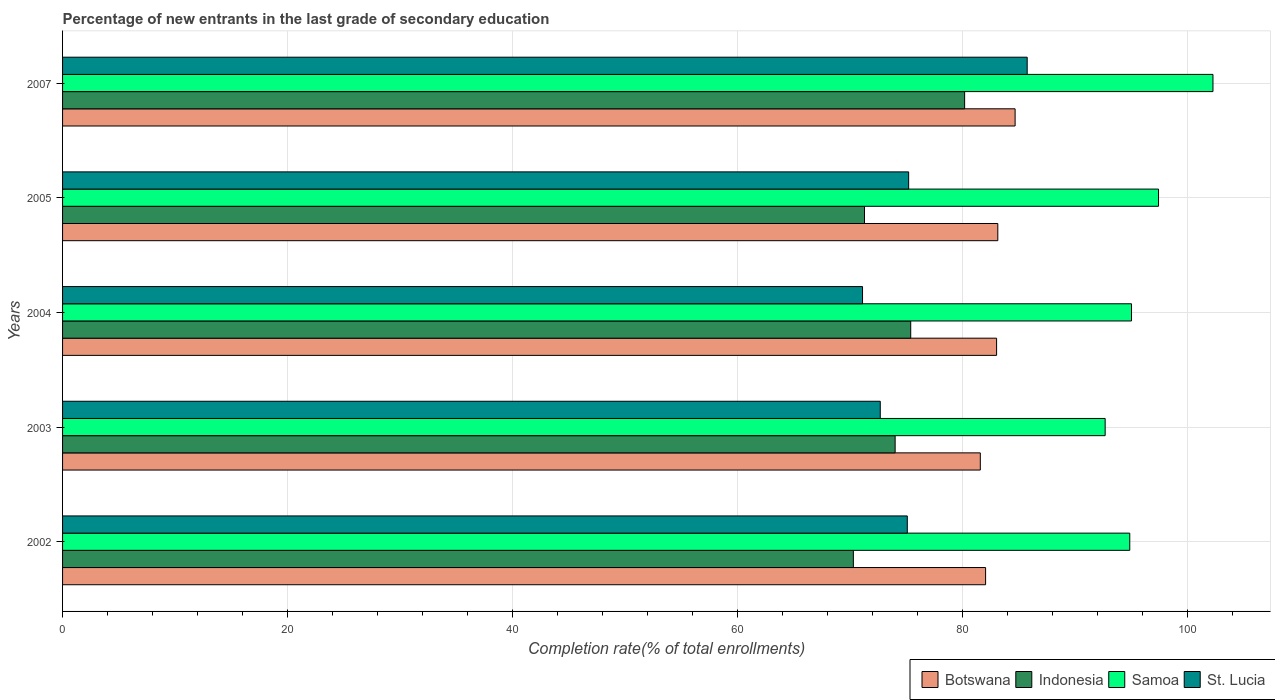How many different coloured bars are there?
Your answer should be compact. 4. Are the number of bars per tick equal to the number of legend labels?
Your answer should be compact. Yes. How many bars are there on the 4th tick from the top?
Ensure brevity in your answer.  4. How many bars are there on the 2nd tick from the bottom?
Your answer should be very brief. 4. In how many cases, is the number of bars for a given year not equal to the number of legend labels?
Provide a short and direct response. 0. What is the percentage of new entrants in Samoa in 2002?
Your answer should be very brief. 94.86. Across all years, what is the maximum percentage of new entrants in St. Lucia?
Make the answer very short. 85.74. Across all years, what is the minimum percentage of new entrants in Indonesia?
Provide a short and direct response. 70.29. In which year was the percentage of new entrants in Samoa maximum?
Offer a very short reply. 2007. In which year was the percentage of new entrants in St. Lucia minimum?
Your answer should be very brief. 2004. What is the total percentage of new entrants in Botswana in the graph?
Offer a very short reply. 414.44. What is the difference between the percentage of new entrants in Indonesia in 2004 and that in 2007?
Your answer should be compact. -4.79. What is the difference between the percentage of new entrants in Samoa in 2005 and the percentage of new entrants in St. Lucia in 2003?
Your answer should be very brief. 24.73. What is the average percentage of new entrants in St. Lucia per year?
Offer a very short reply. 75.97. In the year 2004, what is the difference between the percentage of new entrants in St. Lucia and percentage of new entrants in Indonesia?
Give a very brief answer. -4.28. In how many years, is the percentage of new entrants in St. Lucia greater than 92 %?
Offer a very short reply. 0. What is the ratio of the percentage of new entrants in Botswana in 2003 to that in 2007?
Provide a short and direct response. 0.96. Is the percentage of new entrants in Botswana in 2004 less than that in 2007?
Your response must be concise. Yes. Is the difference between the percentage of new entrants in St. Lucia in 2003 and 2005 greater than the difference between the percentage of new entrants in Indonesia in 2003 and 2005?
Your answer should be very brief. No. What is the difference between the highest and the second highest percentage of new entrants in Samoa?
Your answer should be compact. 4.84. What is the difference between the highest and the lowest percentage of new entrants in Botswana?
Offer a terse response. 3.09. Is the sum of the percentage of new entrants in Samoa in 2002 and 2004 greater than the maximum percentage of new entrants in Botswana across all years?
Ensure brevity in your answer.  Yes. Is it the case that in every year, the sum of the percentage of new entrants in Indonesia and percentage of new entrants in Samoa is greater than the sum of percentage of new entrants in Botswana and percentage of new entrants in St. Lucia?
Keep it short and to the point. Yes. What does the 2nd bar from the top in 2003 represents?
Ensure brevity in your answer.  Samoa. What does the 1st bar from the bottom in 2007 represents?
Ensure brevity in your answer.  Botswana. Is it the case that in every year, the sum of the percentage of new entrants in Botswana and percentage of new entrants in Indonesia is greater than the percentage of new entrants in Samoa?
Make the answer very short. Yes. How many bars are there?
Ensure brevity in your answer.  20. What is the difference between two consecutive major ticks on the X-axis?
Keep it short and to the point. 20. Are the values on the major ticks of X-axis written in scientific E-notation?
Provide a short and direct response. No. How many legend labels are there?
Keep it short and to the point. 4. How are the legend labels stacked?
Your response must be concise. Horizontal. What is the title of the graph?
Offer a very short reply. Percentage of new entrants in the last grade of secondary education. Does "Bahrain" appear as one of the legend labels in the graph?
Provide a succinct answer. No. What is the label or title of the X-axis?
Your answer should be compact. Completion rate(% of total enrollments). What is the Completion rate(% of total enrollments) in Botswana in 2002?
Make the answer very short. 82.05. What is the Completion rate(% of total enrollments) in Indonesia in 2002?
Offer a terse response. 70.29. What is the Completion rate(% of total enrollments) of Samoa in 2002?
Provide a short and direct response. 94.86. What is the Completion rate(% of total enrollments) of St. Lucia in 2002?
Ensure brevity in your answer.  75.09. What is the Completion rate(% of total enrollments) in Botswana in 2003?
Your answer should be very brief. 81.58. What is the Completion rate(% of total enrollments) of Indonesia in 2003?
Make the answer very short. 74.01. What is the Completion rate(% of total enrollments) in Samoa in 2003?
Provide a short and direct response. 92.67. What is the Completion rate(% of total enrollments) in St. Lucia in 2003?
Give a very brief answer. 72.68. What is the Completion rate(% of total enrollments) of Botswana in 2004?
Ensure brevity in your answer.  83.02. What is the Completion rate(% of total enrollments) of Indonesia in 2004?
Your response must be concise. 75.39. What is the Completion rate(% of total enrollments) in Samoa in 2004?
Make the answer very short. 95.01. What is the Completion rate(% of total enrollments) of St. Lucia in 2004?
Offer a very short reply. 71.11. What is the Completion rate(% of total enrollments) of Botswana in 2005?
Provide a short and direct response. 83.13. What is the Completion rate(% of total enrollments) of Indonesia in 2005?
Offer a terse response. 71.28. What is the Completion rate(% of total enrollments) of Samoa in 2005?
Your answer should be very brief. 97.42. What is the Completion rate(% of total enrollments) of St. Lucia in 2005?
Provide a short and direct response. 75.21. What is the Completion rate(% of total enrollments) in Botswana in 2007?
Make the answer very short. 84.67. What is the Completion rate(% of total enrollments) of Indonesia in 2007?
Your answer should be compact. 80.18. What is the Completion rate(% of total enrollments) in Samoa in 2007?
Your answer should be very brief. 102.26. What is the Completion rate(% of total enrollments) in St. Lucia in 2007?
Your answer should be compact. 85.74. Across all years, what is the maximum Completion rate(% of total enrollments) of Botswana?
Give a very brief answer. 84.67. Across all years, what is the maximum Completion rate(% of total enrollments) of Indonesia?
Your answer should be very brief. 80.18. Across all years, what is the maximum Completion rate(% of total enrollments) in Samoa?
Offer a terse response. 102.26. Across all years, what is the maximum Completion rate(% of total enrollments) of St. Lucia?
Offer a very short reply. 85.74. Across all years, what is the minimum Completion rate(% of total enrollments) of Botswana?
Make the answer very short. 81.58. Across all years, what is the minimum Completion rate(% of total enrollments) of Indonesia?
Ensure brevity in your answer.  70.29. Across all years, what is the minimum Completion rate(% of total enrollments) of Samoa?
Make the answer very short. 92.67. Across all years, what is the minimum Completion rate(% of total enrollments) in St. Lucia?
Your response must be concise. 71.11. What is the total Completion rate(% of total enrollments) of Botswana in the graph?
Your response must be concise. 414.44. What is the total Completion rate(% of total enrollments) of Indonesia in the graph?
Provide a short and direct response. 371.15. What is the total Completion rate(% of total enrollments) of Samoa in the graph?
Give a very brief answer. 482.22. What is the total Completion rate(% of total enrollments) of St. Lucia in the graph?
Ensure brevity in your answer.  379.83. What is the difference between the Completion rate(% of total enrollments) in Botswana in 2002 and that in 2003?
Provide a succinct answer. 0.47. What is the difference between the Completion rate(% of total enrollments) of Indonesia in 2002 and that in 2003?
Provide a short and direct response. -3.71. What is the difference between the Completion rate(% of total enrollments) in Samoa in 2002 and that in 2003?
Give a very brief answer. 2.19. What is the difference between the Completion rate(% of total enrollments) of St. Lucia in 2002 and that in 2003?
Offer a very short reply. 2.4. What is the difference between the Completion rate(% of total enrollments) of Botswana in 2002 and that in 2004?
Your answer should be very brief. -0.98. What is the difference between the Completion rate(% of total enrollments) of Indonesia in 2002 and that in 2004?
Your answer should be compact. -5.1. What is the difference between the Completion rate(% of total enrollments) of Samoa in 2002 and that in 2004?
Offer a terse response. -0.15. What is the difference between the Completion rate(% of total enrollments) in St. Lucia in 2002 and that in 2004?
Provide a succinct answer. 3.98. What is the difference between the Completion rate(% of total enrollments) of Botswana in 2002 and that in 2005?
Offer a very short reply. -1.08. What is the difference between the Completion rate(% of total enrollments) of Indonesia in 2002 and that in 2005?
Your response must be concise. -0.99. What is the difference between the Completion rate(% of total enrollments) of Samoa in 2002 and that in 2005?
Your answer should be compact. -2.56. What is the difference between the Completion rate(% of total enrollments) in St. Lucia in 2002 and that in 2005?
Provide a succinct answer. -0.12. What is the difference between the Completion rate(% of total enrollments) in Botswana in 2002 and that in 2007?
Your answer should be compact. -2.62. What is the difference between the Completion rate(% of total enrollments) in Indonesia in 2002 and that in 2007?
Make the answer very short. -9.89. What is the difference between the Completion rate(% of total enrollments) of Samoa in 2002 and that in 2007?
Provide a short and direct response. -7.4. What is the difference between the Completion rate(% of total enrollments) of St. Lucia in 2002 and that in 2007?
Make the answer very short. -10.66. What is the difference between the Completion rate(% of total enrollments) in Botswana in 2003 and that in 2004?
Your answer should be compact. -1.45. What is the difference between the Completion rate(% of total enrollments) of Indonesia in 2003 and that in 2004?
Your answer should be very brief. -1.38. What is the difference between the Completion rate(% of total enrollments) of Samoa in 2003 and that in 2004?
Ensure brevity in your answer.  -2.34. What is the difference between the Completion rate(% of total enrollments) of St. Lucia in 2003 and that in 2004?
Provide a succinct answer. 1.58. What is the difference between the Completion rate(% of total enrollments) in Botswana in 2003 and that in 2005?
Provide a short and direct response. -1.56. What is the difference between the Completion rate(% of total enrollments) of Indonesia in 2003 and that in 2005?
Keep it short and to the point. 2.72. What is the difference between the Completion rate(% of total enrollments) in Samoa in 2003 and that in 2005?
Provide a succinct answer. -4.74. What is the difference between the Completion rate(% of total enrollments) in St. Lucia in 2003 and that in 2005?
Make the answer very short. -2.52. What is the difference between the Completion rate(% of total enrollments) in Botswana in 2003 and that in 2007?
Keep it short and to the point. -3.09. What is the difference between the Completion rate(% of total enrollments) of Indonesia in 2003 and that in 2007?
Your answer should be very brief. -6.18. What is the difference between the Completion rate(% of total enrollments) in Samoa in 2003 and that in 2007?
Your response must be concise. -9.58. What is the difference between the Completion rate(% of total enrollments) of St. Lucia in 2003 and that in 2007?
Ensure brevity in your answer.  -13.06. What is the difference between the Completion rate(% of total enrollments) of Botswana in 2004 and that in 2005?
Ensure brevity in your answer.  -0.11. What is the difference between the Completion rate(% of total enrollments) of Indonesia in 2004 and that in 2005?
Give a very brief answer. 4.11. What is the difference between the Completion rate(% of total enrollments) in Samoa in 2004 and that in 2005?
Ensure brevity in your answer.  -2.4. What is the difference between the Completion rate(% of total enrollments) of St. Lucia in 2004 and that in 2005?
Offer a terse response. -4.1. What is the difference between the Completion rate(% of total enrollments) in Botswana in 2004 and that in 2007?
Provide a short and direct response. -1.65. What is the difference between the Completion rate(% of total enrollments) in Indonesia in 2004 and that in 2007?
Your answer should be compact. -4.79. What is the difference between the Completion rate(% of total enrollments) of Samoa in 2004 and that in 2007?
Keep it short and to the point. -7.24. What is the difference between the Completion rate(% of total enrollments) of St. Lucia in 2004 and that in 2007?
Keep it short and to the point. -14.64. What is the difference between the Completion rate(% of total enrollments) in Botswana in 2005 and that in 2007?
Provide a short and direct response. -1.54. What is the difference between the Completion rate(% of total enrollments) in Indonesia in 2005 and that in 2007?
Keep it short and to the point. -8.9. What is the difference between the Completion rate(% of total enrollments) in Samoa in 2005 and that in 2007?
Make the answer very short. -4.84. What is the difference between the Completion rate(% of total enrollments) of St. Lucia in 2005 and that in 2007?
Offer a very short reply. -10.54. What is the difference between the Completion rate(% of total enrollments) of Botswana in 2002 and the Completion rate(% of total enrollments) of Indonesia in 2003?
Give a very brief answer. 8.04. What is the difference between the Completion rate(% of total enrollments) in Botswana in 2002 and the Completion rate(% of total enrollments) in Samoa in 2003?
Your answer should be very brief. -10.63. What is the difference between the Completion rate(% of total enrollments) in Botswana in 2002 and the Completion rate(% of total enrollments) in St. Lucia in 2003?
Give a very brief answer. 9.36. What is the difference between the Completion rate(% of total enrollments) in Indonesia in 2002 and the Completion rate(% of total enrollments) in Samoa in 2003?
Your response must be concise. -22.38. What is the difference between the Completion rate(% of total enrollments) in Indonesia in 2002 and the Completion rate(% of total enrollments) in St. Lucia in 2003?
Give a very brief answer. -2.39. What is the difference between the Completion rate(% of total enrollments) of Samoa in 2002 and the Completion rate(% of total enrollments) of St. Lucia in 2003?
Provide a short and direct response. 22.18. What is the difference between the Completion rate(% of total enrollments) in Botswana in 2002 and the Completion rate(% of total enrollments) in Indonesia in 2004?
Offer a very short reply. 6.66. What is the difference between the Completion rate(% of total enrollments) of Botswana in 2002 and the Completion rate(% of total enrollments) of Samoa in 2004?
Ensure brevity in your answer.  -12.97. What is the difference between the Completion rate(% of total enrollments) of Botswana in 2002 and the Completion rate(% of total enrollments) of St. Lucia in 2004?
Your answer should be compact. 10.94. What is the difference between the Completion rate(% of total enrollments) of Indonesia in 2002 and the Completion rate(% of total enrollments) of Samoa in 2004?
Ensure brevity in your answer.  -24.72. What is the difference between the Completion rate(% of total enrollments) in Indonesia in 2002 and the Completion rate(% of total enrollments) in St. Lucia in 2004?
Provide a short and direct response. -0.82. What is the difference between the Completion rate(% of total enrollments) in Samoa in 2002 and the Completion rate(% of total enrollments) in St. Lucia in 2004?
Offer a terse response. 23.75. What is the difference between the Completion rate(% of total enrollments) in Botswana in 2002 and the Completion rate(% of total enrollments) in Indonesia in 2005?
Provide a succinct answer. 10.76. What is the difference between the Completion rate(% of total enrollments) of Botswana in 2002 and the Completion rate(% of total enrollments) of Samoa in 2005?
Your answer should be compact. -15.37. What is the difference between the Completion rate(% of total enrollments) in Botswana in 2002 and the Completion rate(% of total enrollments) in St. Lucia in 2005?
Provide a short and direct response. 6.84. What is the difference between the Completion rate(% of total enrollments) of Indonesia in 2002 and the Completion rate(% of total enrollments) of Samoa in 2005?
Offer a very short reply. -27.13. What is the difference between the Completion rate(% of total enrollments) in Indonesia in 2002 and the Completion rate(% of total enrollments) in St. Lucia in 2005?
Offer a very short reply. -4.92. What is the difference between the Completion rate(% of total enrollments) in Samoa in 2002 and the Completion rate(% of total enrollments) in St. Lucia in 2005?
Your response must be concise. 19.65. What is the difference between the Completion rate(% of total enrollments) in Botswana in 2002 and the Completion rate(% of total enrollments) in Indonesia in 2007?
Provide a succinct answer. 1.86. What is the difference between the Completion rate(% of total enrollments) in Botswana in 2002 and the Completion rate(% of total enrollments) in Samoa in 2007?
Give a very brief answer. -20.21. What is the difference between the Completion rate(% of total enrollments) in Botswana in 2002 and the Completion rate(% of total enrollments) in St. Lucia in 2007?
Ensure brevity in your answer.  -3.7. What is the difference between the Completion rate(% of total enrollments) of Indonesia in 2002 and the Completion rate(% of total enrollments) of Samoa in 2007?
Ensure brevity in your answer.  -31.96. What is the difference between the Completion rate(% of total enrollments) in Indonesia in 2002 and the Completion rate(% of total enrollments) in St. Lucia in 2007?
Offer a very short reply. -15.45. What is the difference between the Completion rate(% of total enrollments) of Samoa in 2002 and the Completion rate(% of total enrollments) of St. Lucia in 2007?
Your answer should be compact. 9.12. What is the difference between the Completion rate(% of total enrollments) in Botswana in 2003 and the Completion rate(% of total enrollments) in Indonesia in 2004?
Provide a succinct answer. 6.19. What is the difference between the Completion rate(% of total enrollments) of Botswana in 2003 and the Completion rate(% of total enrollments) of Samoa in 2004?
Provide a succinct answer. -13.44. What is the difference between the Completion rate(% of total enrollments) of Botswana in 2003 and the Completion rate(% of total enrollments) of St. Lucia in 2004?
Provide a short and direct response. 10.47. What is the difference between the Completion rate(% of total enrollments) of Indonesia in 2003 and the Completion rate(% of total enrollments) of Samoa in 2004?
Your response must be concise. -21.01. What is the difference between the Completion rate(% of total enrollments) of Indonesia in 2003 and the Completion rate(% of total enrollments) of St. Lucia in 2004?
Your answer should be compact. 2.9. What is the difference between the Completion rate(% of total enrollments) in Samoa in 2003 and the Completion rate(% of total enrollments) in St. Lucia in 2004?
Offer a terse response. 21.57. What is the difference between the Completion rate(% of total enrollments) in Botswana in 2003 and the Completion rate(% of total enrollments) in Indonesia in 2005?
Provide a short and direct response. 10.29. What is the difference between the Completion rate(% of total enrollments) in Botswana in 2003 and the Completion rate(% of total enrollments) in Samoa in 2005?
Offer a very short reply. -15.84. What is the difference between the Completion rate(% of total enrollments) of Botswana in 2003 and the Completion rate(% of total enrollments) of St. Lucia in 2005?
Your response must be concise. 6.37. What is the difference between the Completion rate(% of total enrollments) in Indonesia in 2003 and the Completion rate(% of total enrollments) in Samoa in 2005?
Give a very brief answer. -23.41. What is the difference between the Completion rate(% of total enrollments) of Indonesia in 2003 and the Completion rate(% of total enrollments) of St. Lucia in 2005?
Offer a terse response. -1.2. What is the difference between the Completion rate(% of total enrollments) of Samoa in 2003 and the Completion rate(% of total enrollments) of St. Lucia in 2005?
Your response must be concise. 17.47. What is the difference between the Completion rate(% of total enrollments) in Botswana in 2003 and the Completion rate(% of total enrollments) in Indonesia in 2007?
Provide a succinct answer. 1.39. What is the difference between the Completion rate(% of total enrollments) of Botswana in 2003 and the Completion rate(% of total enrollments) of Samoa in 2007?
Your response must be concise. -20.68. What is the difference between the Completion rate(% of total enrollments) of Botswana in 2003 and the Completion rate(% of total enrollments) of St. Lucia in 2007?
Provide a short and direct response. -4.17. What is the difference between the Completion rate(% of total enrollments) of Indonesia in 2003 and the Completion rate(% of total enrollments) of Samoa in 2007?
Provide a succinct answer. -28.25. What is the difference between the Completion rate(% of total enrollments) in Indonesia in 2003 and the Completion rate(% of total enrollments) in St. Lucia in 2007?
Your answer should be compact. -11.74. What is the difference between the Completion rate(% of total enrollments) in Samoa in 2003 and the Completion rate(% of total enrollments) in St. Lucia in 2007?
Your answer should be very brief. 6.93. What is the difference between the Completion rate(% of total enrollments) in Botswana in 2004 and the Completion rate(% of total enrollments) in Indonesia in 2005?
Offer a terse response. 11.74. What is the difference between the Completion rate(% of total enrollments) of Botswana in 2004 and the Completion rate(% of total enrollments) of Samoa in 2005?
Provide a short and direct response. -14.39. What is the difference between the Completion rate(% of total enrollments) of Botswana in 2004 and the Completion rate(% of total enrollments) of St. Lucia in 2005?
Give a very brief answer. 7.82. What is the difference between the Completion rate(% of total enrollments) of Indonesia in 2004 and the Completion rate(% of total enrollments) of Samoa in 2005?
Make the answer very short. -22.03. What is the difference between the Completion rate(% of total enrollments) in Indonesia in 2004 and the Completion rate(% of total enrollments) in St. Lucia in 2005?
Make the answer very short. 0.18. What is the difference between the Completion rate(% of total enrollments) of Samoa in 2004 and the Completion rate(% of total enrollments) of St. Lucia in 2005?
Ensure brevity in your answer.  19.81. What is the difference between the Completion rate(% of total enrollments) of Botswana in 2004 and the Completion rate(% of total enrollments) of Indonesia in 2007?
Ensure brevity in your answer.  2.84. What is the difference between the Completion rate(% of total enrollments) of Botswana in 2004 and the Completion rate(% of total enrollments) of Samoa in 2007?
Make the answer very short. -19.23. What is the difference between the Completion rate(% of total enrollments) of Botswana in 2004 and the Completion rate(% of total enrollments) of St. Lucia in 2007?
Ensure brevity in your answer.  -2.72. What is the difference between the Completion rate(% of total enrollments) of Indonesia in 2004 and the Completion rate(% of total enrollments) of Samoa in 2007?
Give a very brief answer. -26.87. What is the difference between the Completion rate(% of total enrollments) of Indonesia in 2004 and the Completion rate(% of total enrollments) of St. Lucia in 2007?
Offer a terse response. -10.35. What is the difference between the Completion rate(% of total enrollments) of Samoa in 2004 and the Completion rate(% of total enrollments) of St. Lucia in 2007?
Give a very brief answer. 9.27. What is the difference between the Completion rate(% of total enrollments) in Botswana in 2005 and the Completion rate(% of total enrollments) in Indonesia in 2007?
Offer a very short reply. 2.95. What is the difference between the Completion rate(% of total enrollments) in Botswana in 2005 and the Completion rate(% of total enrollments) in Samoa in 2007?
Keep it short and to the point. -19.13. What is the difference between the Completion rate(% of total enrollments) of Botswana in 2005 and the Completion rate(% of total enrollments) of St. Lucia in 2007?
Offer a terse response. -2.61. What is the difference between the Completion rate(% of total enrollments) of Indonesia in 2005 and the Completion rate(% of total enrollments) of Samoa in 2007?
Make the answer very short. -30.97. What is the difference between the Completion rate(% of total enrollments) of Indonesia in 2005 and the Completion rate(% of total enrollments) of St. Lucia in 2007?
Make the answer very short. -14.46. What is the difference between the Completion rate(% of total enrollments) of Samoa in 2005 and the Completion rate(% of total enrollments) of St. Lucia in 2007?
Give a very brief answer. 11.67. What is the average Completion rate(% of total enrollments) of Botswana per year?
Your answer should be compact. 82.89. What is the average Completion rate(% of total enrollments) of Indonesia per year?
Offer a terse response. 74.23. What is the average Completion rate(% of total enrollments) in Samoa per year?
Your answer should be very brief. 96.44. What is the average Completion rate(% of total enrollments) of St. Lucia per year?
Make the answer very short. 75.97. In the year 2002, what is the difference between the Completion rate(% of total enrollments) of Botswana and Completion rate(% of total enrollments) of Indonesia?
Ensure brevity in your answer.  11.75. In the year 2002, what is the difference between the Completion rate(% of total enrollments) of Botswana and Completion rate(% of total enrollments) of Samoa?
Ensure brevity in your answer.  -12.82. In the year 2002, what is the difference between the Completion rate(% of total enrollments) in Botswana and Completion rate(% of total enrollments) in St. Lucia?
Offer a terse response. 6.96. In the year 2002, what is the difference between the Completion rate(% of total enrollments) in Indonesia and Completion rate(% of total enrollments) in Samoa?
Provide a succinct answer. -24.57. In the year 2002, what is the difference between the Completion rate(% of total enrollments) of Indonesia and Completion rate(% of total enrollments) of St. Lucia?
Your answer should be compact. -4.79. In the year 2002, what is the difference between the Completion rate(% of total enrollments) of Samoa and Completion rate(% of total enrollments) of St. Lucia?
Offer a very short reply. 19.77. In the year 2003, what is the difference between the Completion rate(% of total enrollments) in Botswana and Completion rate(% of total enrollments) in Indonesia?
Provide a succinct answer. 7.57. In the year 2003, what is the difference between the Completion rate(% of total enrollments) in Botswana and Completion rate(% of total enrollments) in Samoa?
Keep it short and to the point. -11.1. In the year 2003, what is the difference between the Completion rate(% of total enrollments) in Botswana and Completion rate(% of total enrollments) in St. Lucia?
Give a very brief answer. 8.89. In the year 2003, what is the difference between the Completion rate(% of total enrollments) of Indonesia and Completion rate(% of total enrollments) of Samoa?
Your answer should be very brief. -18.67. In the year 2003, what is the difference between the Completion rate(% of total enrollments) of Indonesia and Completion rate(% of total enrollments) of St. Lucia?
Your answer should be compact. 1.32. In the year 2003, what is the difference between the Completion rate(% of total enrollments) of Samoa and Completion rate(% of total enrollments) of St. Lucia?
Provide a succinct answer. 19.99. In the year 2004, what is the difference between the Completion rate(% of total enrollments) of Botswana and Completion rate(% of total enrollments) of Indonesia?
Your response must be concise. 7.63. In the year 2004, what is the difference between the Completion rate(% of total enrollments) of Botswana and Completion rate(% of total enrollments) of Samoa?
Offer a terse response. -11.99. In the year 2004, what is the difference between the Completion rate(% of total enrollments) in Botswana and Completion rate(% of total enrollments) in St. Lucia?
Your answer should be very brief. 11.92. In the year 2004, what is the difference between the Completion rate(% of total enrollments) of Indonesia and Completion rate(% of total enrollments) of Samoa?
Ensure brevity in your answer.  -19.62. In the year 2004, what is the difference between the Completion rate(% of total enrollments) of Indonesia and Completion rate(% of total enrollments) of St. Lucia?
Provide a succinct answer. 4.28. In the year 2004, what is the difference between the Completion rate(% of total enrollments) of Samoa and Completion rate(% of total enrollments) of St. Lucia?
Provide a succinct answer. 23.91. In the year 2005, what is the difference between the Completion rate(% of total enrollments) in Botswana and Completion rate(% of total enrollments) in Indonesia?
Your response must be concise. 11.85. In the year 2005, what is the difference between the Completion rate(% of total enrollments) of Botswana and Completion rate(% of total enrollments) of Samoa?
Your answer should be compact. -14.29. In the year 2005, what is the difference between the Completion rate(% of total enrollments) of Botswana and Completion rate(% of total enrollments) of St. Lucia?
Offer a very short reply. 7.92. In the year 2005, what is the difference between the Completion rate(% of total enrollments) of Indonesia and Completion rate(% of total enrollments) of Samoa?
Your answer should be very brief. -26.14. In the year 2005, what is the difference between the Completion rate(% of total enrollments) of Indonesia and Completion rate(% of total enrollments) of St. Lucia?
Ensure brevity in your answer.  -3.93. In the year 2005, what is the difference between the Completion rate(% of total enrollments) of Samoa and Completion rate(% of total enrollments) of St. Lucia?
Keep it short and to the point. 22.21. In the year 2007, what is the difference between the Completion rate(% of total enrollments) in Botswana and Completion rate(% of total enrollments) in Indonesia?
Offer a very short reply. 4.49. In the year 2007, what is the difference between the Completion rate(% of total enrollments) of Botswana and Completion rate(% of total enrollments) of Samoa?
Provide a succinct answer. -17.59. In the year 2007, what is the difference between the Completion rate(% of total enrollments) in Botswana and Completion rate(% of total enrollments) in St. Lucia?
Give a very brief answer. -1.07. In the year 2007, what is the difference between the Completion rate(% of total enrollments) of Indonesia and Completion rate(% of total enrollments) of Samoa?
Your answer should be very brief. -22.07. In the year 2007, what is the difference between the Completion rate(% of total enrollments) of Indonesia and Completion rate(% of total enrollments) of St. Lucia?
Keep it short and to the point. -5.56. In the year 2007, what is the difference between the Completion rate(% of total enrollments) in Samoa and Completion rate(% of total enrollments) in St. Lucia?
Offer a terse response. 16.51. What is the ratio of the Completion rate(% of total enrollments) of Botswana in 2002 to that in 2003?
Your answer should be compact. 1.01. What is the ratio of the Completion rate(% of total enrollments) in Indonesia in 2002 to that in 2003?
Offer a terse response. 0.95. What is the ratio of the Completion rate(% of total enrollments) in Samoa in 2002 to that in 2003?
Give a very brief answer. 1.02. What is the ratio of the Completion rate(% of total enrollments) of St. Lucia in 2002 to that in 2003?
Make the answer very short. 1.03. What is the ratio of the Completion rate(% of total enrollments) of Indonesia in 2002 to that in 2004?
Provide a succinct answer. 0.93. What is the ratio of the Completion rate(% of total enrollments) in Samoa in 2002 to that in 2004?
Offer a terse response. 1. What is the ratio of the Completion rate(% of total enrollments) in St. Lucia in 2002 to that in 2004?
Offer a very short reply. 1.06. What is the ratio of the Completion rate(% of total enrollments) of Botswana in 2002 to that in 2005?
Offer a terse response. 0.99. What is the ratio of the Completion rate(% of total enrollments) in Indonesia in 2002 to that in 2005?
Provide a succinct answer. 0.99. What is the ratio of the Completion rate(% of total enrollments) in Samoa in 2002 to that in 2005?
Provide a short and direct response. 0.97. What is the ratio of the Completion rate(% of total enrollments) of St. Lucia in 2002 to that in 2005?
Your answer should be compact. 1. What is the ratio of the Completion rate(% of total enrollments) of Botswana in 2002 to that in 2007?
Your answer should be compact. 0.97. What is the ratio of the Completion rate(% of total enrollments) of Indonesia in 2002 to that in 2007?
Your answer should be very brief. 0.88. What is the ratio of the Completion rate(% of total enrollments) of Samoa in 2002 to that in 2007?
Offer a very short reply. 0.93. What is the ratio of the Completion rate(% of total enrollments) in St. Lucia in 2002 to that in 2007?
Provide a short and direct response. 0.88. What is the ratio of the Completion rate(% of total enrollments) in Botswana in 2003 to that in 2004?
Your answer should be very brief. 0.98. What is the ratio of the Completion rate(% of total enrollments) of Indonesia in 2003 to that in 2004?
Provide a succinct answer. 0.98. What is the ratio of the Completion rate(% of total enrollments) of Samoa in 2003 to that in 2004?
Offer a terse response. 0.98. What is the ratio of the Completion rate(% of total enrollments) in St. Lucia in 2003 to that in 2004?
Keep it short and to the point. 1.02. What is the ratio of the Completion rate(% of total enrollments) of Botswana in 2003 to that in 2005?
Your response must be concise. 0.98. What is the ratio of the Completion rate(% of total enrollments) of Indonesia in 2003 to that in 2005?
Provide a succinct answer. 1.04. What is the ratio of the Completion rate(% of total enrollments) in Samoa in 2003 to that in 2005?
Offer a very short reply. 0.95. What is the ratio of the Completion rate(% of total enrollments) of St. Lucia in 2003 to that in 2005?
Provide a short and direct response. 0.97. What is the ratio of the Completion rate(% of total enrollments) of Botswana in 2003 to that in 2007?
Your answer should be very brief. 0.96. What is the ratio of the Completion rate(% of total enrollments) of Indonesia in 2003 to that in 2007?
Keep it short and to the point. 0.92. What is the ratio of the Completion rate(% of total enrollments) in Samoa in 2003 to that in 2007?
Keep it short and to the point. 0.91. What is the ratio of the Completion rate(% of total enrollments) of St. Lucia in 2003 to that in 2007?
Keep it short and to the point. 0.85. What is the ratio of the Completion rate(% of total enrollments) of Indonesia in 2004 to that in 2005?
Your response must be concise. 1.06. What is the ratio of the Completion rate(% of total enrollments) in Samoa in 2004 to that in 2005?
Offer a very short reply. 0.98. What is the ratio of the Completion rate(% of total enrollments) of St. Lucia in 2004 to that in 2005?
Give a very brief answer. 0.95. What is the ratio of the Completion rate(% of total enrollments) of Botswana in 2004 to that in 2007?
Your answer should be very brief. 0.98. What is the ratio of the Completion rate(% of total enrollments) in Indonesia in 2004 to that in 2007?
Your answer should be very brief. 0.94. What is the ratio of the Completion rate(% of total enrollments) of Samoa in 2004 to that in 2007?
Provide a succinct answer. 0.93. What is the ratio of the Completion rate(% of total enrollments) of St. Lucia in 2004 to that in 2007?
Provide a succinct answer. 0.83. What is the ratio of the Completion rate(% of total enrollments) in Botswana in 2005 to that in 2007?
Your answer should be compact. 0.98. What is the ratio of the Completion rate(% of total enrollments) in Indonesia in 2005 to that in 2007?
Provide a short and direct response. 0.89. What is the ratio of the Completion rate(% of total enrollments) in Samoa in 2005 to that in 2007?
Give a very brief answer. 0.95. What is the ratio of the Completion rate(% of total enrollments) of St. Lucia in 2005 to that in 2007?
Make the answer very short. 0.88. What is the difference between the highest and the second highest Completion rate(% of total enrollments) in Botswana?
Offer a terse response. 1.54. What is the difference between the highest and the second highest Completion rate(% of total enrollments) in Indonesia?
Offer a terse response. 4.79. What is the difference between the highest and the second highest Completion rate(% of total enrollments) of Samoa?
Offer a terse response. 4.84. What is the difference between the highest and the second highest Completion rate(% of total enrollments) in St. Lucia?
Your answer should be very brief. 10.54. What is the difference between the highest and the lowest Completion rate(% of total enrollments) in Botswana?
Your answer should be very brief. 3.09. What is the difference between the highest and the lowest Completion rate(% of total enrollments) in Indonesia?
Keep it short and to the point. 9.89. What is the difference between the highest and the lowest Completion rate(% of total enrollments) in Samoa?
Keep it short and to the point. 9.58. What is the difference between the highest and the lowest Completion rate(% of total enrollments) in St. Lucia?
Keep it short and to the point. 14.64. 